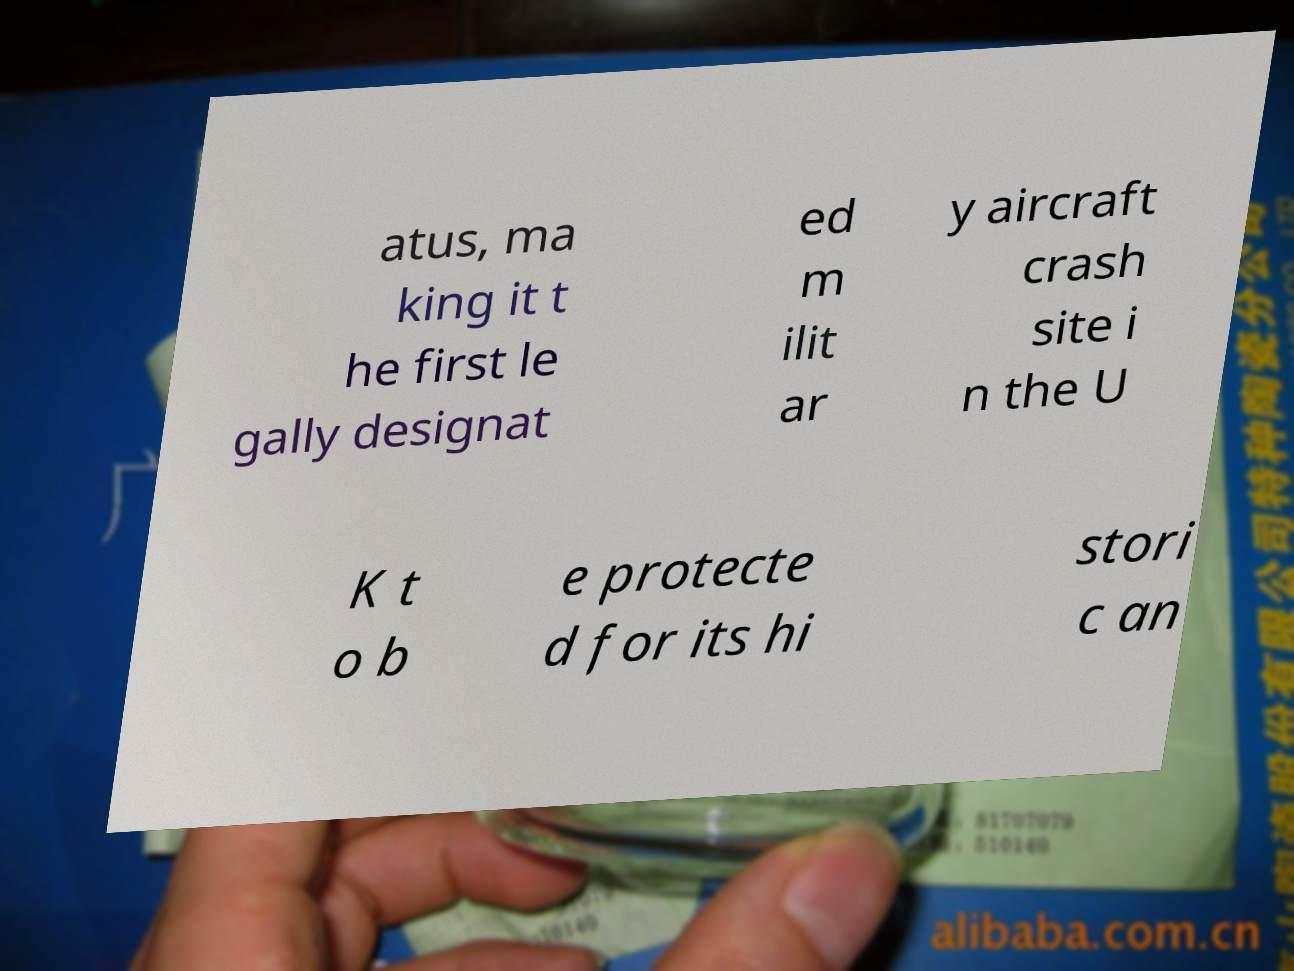Please read and relay the text visible in this image. What does it say? atus, ma king it t he first le gally designat ed m ilit ar y aircraft crash site i n the U K t o b e protecte d for its hi stori c an 